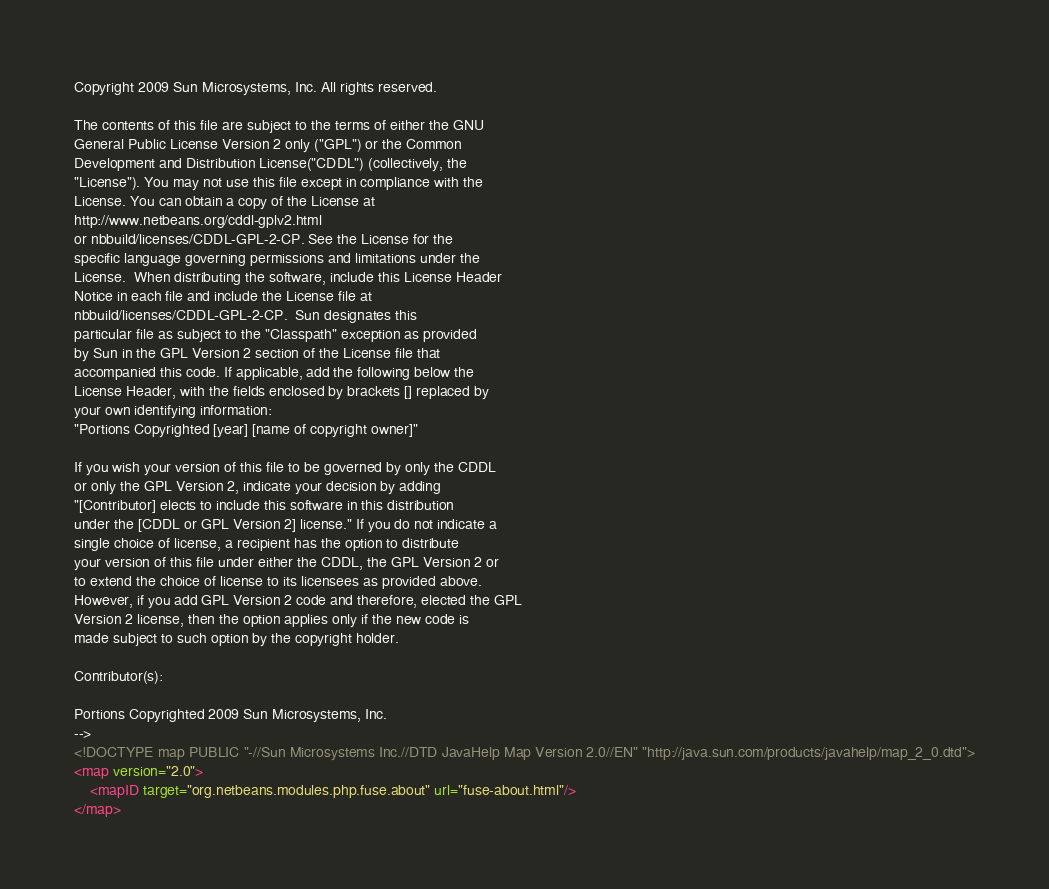Convert code to text. <code><loc_0><loc_0><loc_500><loc_500><_XML_>Copyright 2009 Sun Microsystems, Inc. All rights reserved.

The contents of this file are subject to the terms of either the GNU
General Public License Version 2 only ("GPL") or the Common
Development and Distribution License("CDDL") (collectively, the
"License"). You may not use this file except in compliance with the
License. You can obtain a copy of the License at
http://www.netbeans.org/cddl-gplv2.html
or nbbuild/licenses/CDDL-GPL-2-CP. See the License for the
specific language governing permissions and limitations under the
License.  When distributing the software, include this License Header
Notice in each file and include the License file at
nbbuild/licenses/CDDL-GPL-2-CP.  Sun designates this
particular file as subject to the "Classpath" exception as provided
by Sun in the GPL Version 2 section of the License file that
accompanied this code. If applicable, add the following below the
License Header, with the fields enclosed by brackets [] replaced by
your own identifying information:
"Portions Copyrighted [year] [name of copyright owner]"

If you wish your version of this file to be governed by only the CDDL
or only the GPL Version 2, indicate your decision by adding
"[Contributor] elects to include this software in this distribution
under the [CDDL or GPL Version 2] license." If you do not indicate a
single choice of license, a recipient has the option to distribute
your version of this file under either the CDDL, the GPL Version 2 or
to extend the choice of license to its licensees as provided above.
However, if you add GPL Version 2 code and therefore, elected the GPL
Version 2 license, then the option applies only if the new code is
made subject to such option by the copyright holder.

Contributor(s):

Portions Copyrighted 2009 Sun Microsystems, Inc.
-->
<!DOCTYPE map PUBLIC "-//Sun Microsystems Inc.//DTD JavaHelp Map Version 2.0//EN" "http://java.sun.com/products/javahelp/map_2_0.dtd">
<map version="2.0">
    <mapID target="org.netbeans.modules.php.fuse.about" url="fuse-about.html"/>
</map>
</code> 